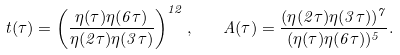<formula> <loc_0><loc_0><loc_500><loc_500>t ( \tau ) = \left ( \frac { \eta ( \tau ) \eta ( 6 \tau ) } { \eta ( 2 \tau ) \eta ( 3 \tau ) } \right ) ^ { 1 2 } , \quad A ( \tau ) = \frac { ( \eta ( 2 \tau ) \eta ( 3 \tau ) ) ^ { 7 } } { ( \eta ( \tau ) \eta ( 6 \tau ) ) ^ { 5 } } .</formula> 